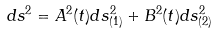<formula> <loc_0><loc_0><loc_500><loc_500>d s ^ { 2 } = A ^ { 2 } ( t ) d s _ { ( 1 ) } ^ { 2 } + B ^ { 2 } ( t ) d s _ { ( 2 ) } ^ { 2 }</formula> 